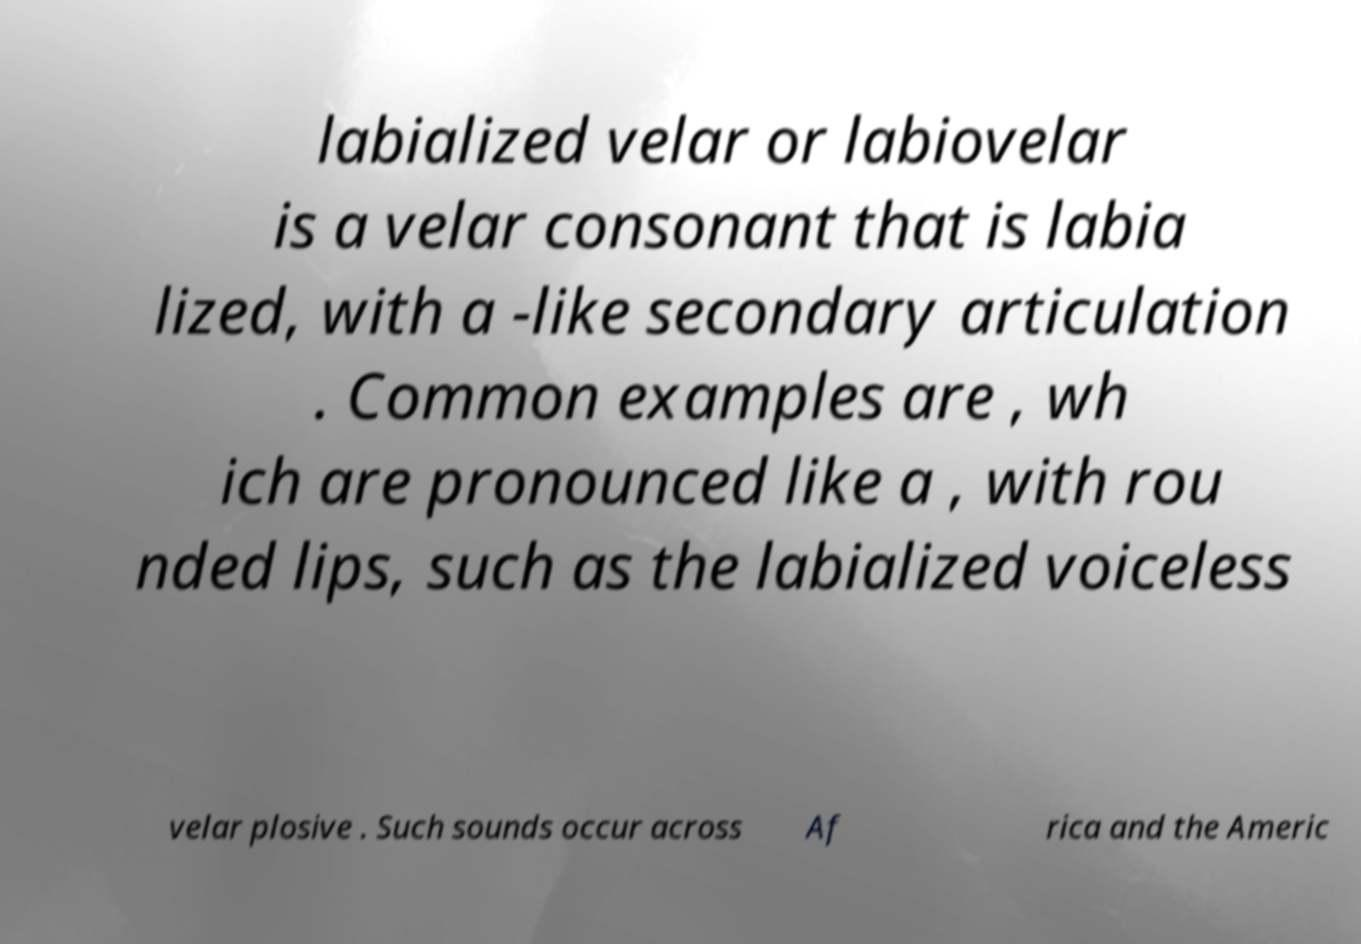Please identify and transcribe the text found in this image. labialized velar or labiovelar is a velar consonant that is labia lized, with a -like secondary articulation . Common examples are , wh ich are pronounced like a , with rou nded lips, such as the labialized voiceless velar plosive . Such sounds occur across Af rica and the Americ 